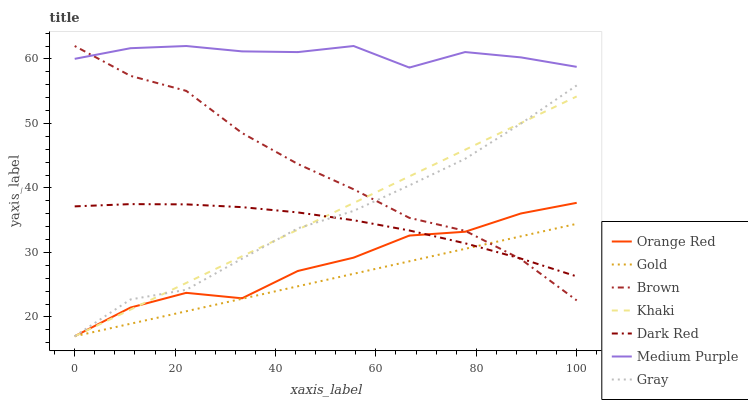Does Gold have the minimum area under the curve?
Answer yes or no. Yes. Does Medium Purple have the maximum area under the curve?
Answer yes or no. Yes. Does Khaki have the minimum area under the curve?
Answer yes or no. No. Does Khaki have the maximum area under the curve?
Answer yes or no. No. Is Gold the smoothest?
Answer yes or no. Yes. Is Orange Red the roughest?
Answer yes or no. Yes. Is Khaki the smoothest?
Answer yes or no. No. Is Khaki the roughest?
Answer yes or no. No. Does Khaki have the lowest value?
Answer yes or no. Yes. Does Dark Red have the lowest value?
Answer yes or no. No. Does Medium Purple have the highest value?
Answer yes or no. Yes. Does Khaki have the highest value?
Answer yes or no. No. Is Dark Red less than Medium Purple?
Answer yes or no. Yes. Is Medium Purple greater than Khaki?
Answer yes or no. Yes. Does Brown intersect Gold?
Answer yes or no. Yes. Is Brown less than Gold?
Answer yes or no. No. Is Brown greater than Gold?
Answer yes or no. No. Does Dark Red intersect Medium Purple?
Answer yes or no. No. 